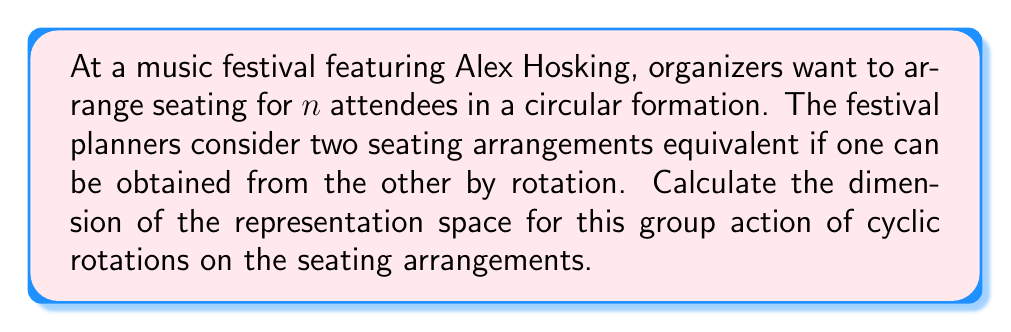Solve this math problem. Let's approach this step-by-step:

1) First, we need to identify the group and its action:
   - The group here is the cyclic group $C_n$ of rotations acting on the set of all possible seating arrangements.

2) The total number of possible seating arrangements without considering rotations is $n!$.

3) However, we consider arrangements equivalent under rotations. This means each orbit under the group action represents a unique seating arrangement.

4) The number of orbits is given by Burnside's lemma:

   $$|\text{Orbits}| = \frac{1}{|G|} \sum_{g \in G} |X^g|$$

   where $|G|$ is the order of the group, and $|X^g|$ is the number of elements fixed by each group element $g$.

5) In this case:
   - $|G| = n$ (the cyclic group $C_n$ has $n$ elements)
   - For the identity element, all $n!$ arrangements are fixed
   - For any non-identity rotation, only arrangements with all seats occupied by the same person are fixed (there are $n$ such arrangements)

6) Applying Burnside's lemma:

   $$|\text{Orbits}| = \frac{1}{n} (n! + (n-1)n)$$

7) This number of orbits represents the dimension of the representation space, as each orbit corresponds to a basis vector in the representation.

Therefore, the dimension of the representation space is:

$$\text{dim} = \frac{1}{n} (n! + (n-1)n)$$
Answer: $\frac{1}{n} (n! + (n-1)n)$ 